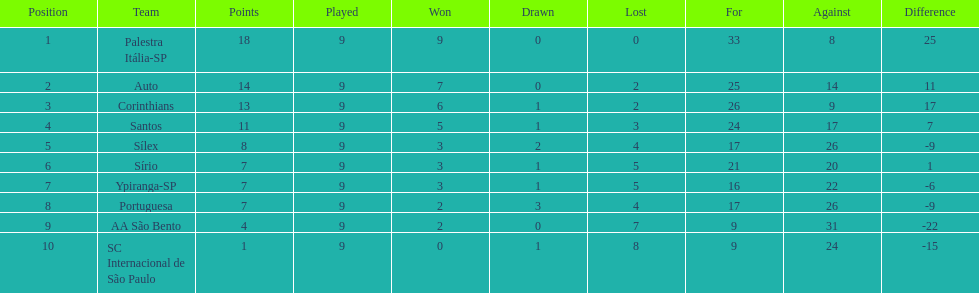In 1926 brazilian soccer, what was the overall sum of points achieved? 90. 